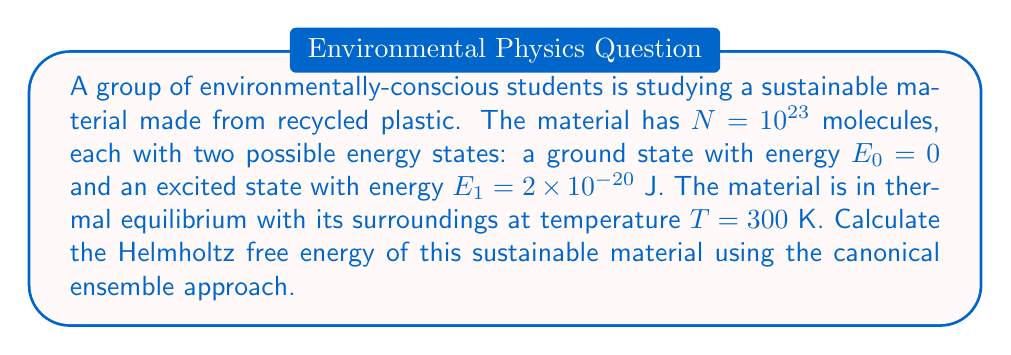Can you solve this math problem? To calculate the Helmholtz free energy using the canonical ensemble, we'll follow these steps:

1) The partition function $Z$ for a single molecule is:
   $$Z_1 = e^{-\beta E_0} + e^{-\beta E_1}$$
   where $\beta = \frac{1}{k_B T}$, and $k_B$ is the Boltzmann constant.

2) Calculate $\beta$:
   $$\beta = \frac{1}{k_B T} = \frac{1}{(1.38 \times 10^{-23} \text{ J/K})(300 \text{ K})} = 2.42 \times 10^{20} \text{ J}^{-1}$$

3) Evaluate $Z_1$:
   $$Z_1 = e^{0} + e^{-\beta E_1} = 1 + e^{-(2.42 \times 10^{20} \text{ J}^{-1})(2 \times 10^{-20} \text{ J})} = 1 + e^{-4.84} = 1.008$$

4) For $N$ independent molecules, the total partition function is:
   $$Z = (Z_1)^N = (1.008)^{10^{23}}$$

5) The Helmholtz free energy $F$ is given by:
   $$F = -k_B T \ln Z$$

6) Substitute the values:
   $$F = -(1.38 \times 10^{-23} \text{ J/K})(300 \text{ K})\ln(1.008)^{10^{23}}$$

7) Simplify:
   $$F = -4.14 \times 10^{-21} \text{ J} \times 10^{23} \ln(1.008) = -3.31 \times 10^2 \text{ J}$$
Answer: $-331$ J 